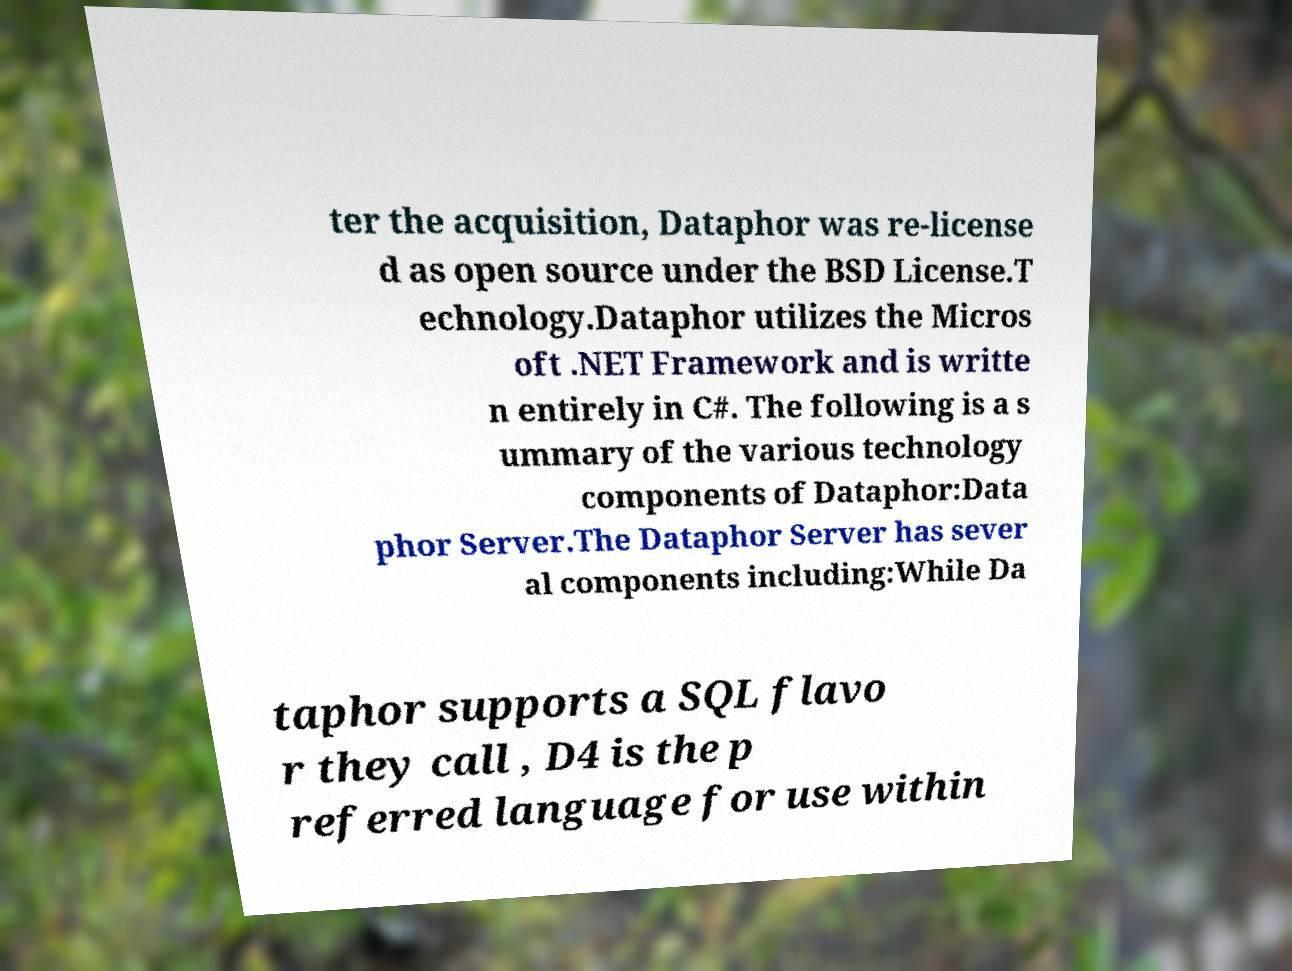Can you read and provide the text displayed in the image?This photo seems to have some interesting text. Can you extract and type it out for me? ter the acquisition, Dataphor was re-license d as open source under the BSD License.T echnology.Dataphor utilizes the Micros oft .NET Framework and is writte n entirely in C#. The following is a s ummary of the various technology components of Dataphor:Data phor Server.The Dataphor Server has sever al components including:While Da taphor supports a SQL flavo r they call , D4 is the p referred language for use within 